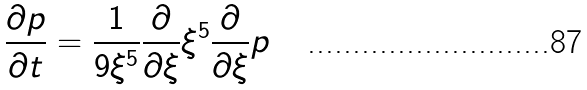Convert formula to latex. <formula><loc_0><loc_0><loc_500><loc_500>\frac { \partial p } { \partial t } = \frac { 1 } { 9 \xi ^ { 5 } } \frac { \partial } { \partial \xi } \xi ^ { 5 } \frac { \partial } { \partial \xi } p</formula> 